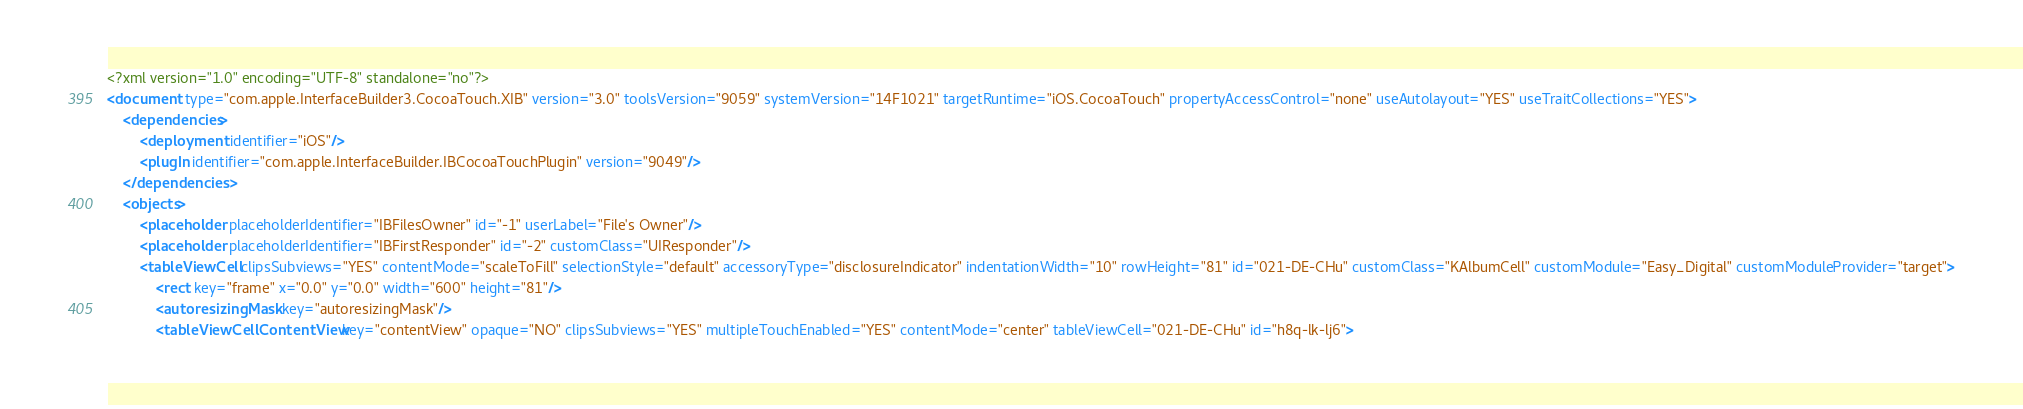Convert code to text. <code><loc_0><loc_0><loc_500><loc_500><_XML_><?xml version="1.0" encoding="UTF-8" standalone="no"?>
<document type="com.apple.InterfaceBuilder3.CocoaTouch.XIB" version="3.0" toolsVersion="9059" systemVersion="14F1021" targetRuntime="iOS.CocoaTouch" propertyAccessControl="none" useAutolayout="YES" useTraitCollections="YES">
    <dependencies>
        <deployment identifier="iOS"/>
        <plugIn identifier="com.apple.InterfaceBuilder.IBCocoaTouchPlugin" version="9049"/>
    </dependencies>
    <objects>
        <placeholder placeholderIdentifier="IBFilesOwner" id="-1" userLabel="File's Owner"/>
        <placeholder placeholderIdentifier="IBFirstResponder" id="-2" customClass="UIResponder"/>
        <tableViewCell clipsSubviews="YES" contentMode="scaleToFill" selectionStyle="default" accessoryType="disclosureIndicator" indentationWidth="10" rowHeight="81" id="021-DE-CHu" customClass="KAlbumCell" customModule="Easy_Digital" customModuleProvider="target">
            <rect key="frame" x="0.0" y="0.0" width="600" height="81"/>
            <autoresizingMask key="autoresizingMask"/>
            <tableViewCellContentView key="contentView" opaque="NO" clipsSubviews="YES" multipleTouchEnabled="YES" contentMode="center" tableViewCell="021-DE-CHu" id="h8q-lk-lj6"></code> 